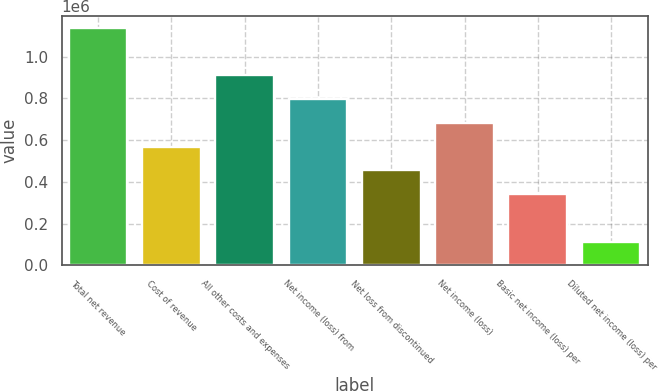Convert chart. <chart><loc_0><loc_0><loc_500><loc_500><bar_chart><fcel>Total net revenue<fcel>Cost of revenue<fcel>All other costs and expenses<fcel>Net income (loss) from<fcel>Net loss from discontinued<fcel>Net income (loss)<fcel>Basic net income (loss) per<fcel>Diluted net income (loss) per<nl><fcel>1.13914e+06<fcel>569573<fcel>911316<fcel>797402<fcel>455659<fcel>683487<fcel>341744<fcel>113915<nl></chart> 